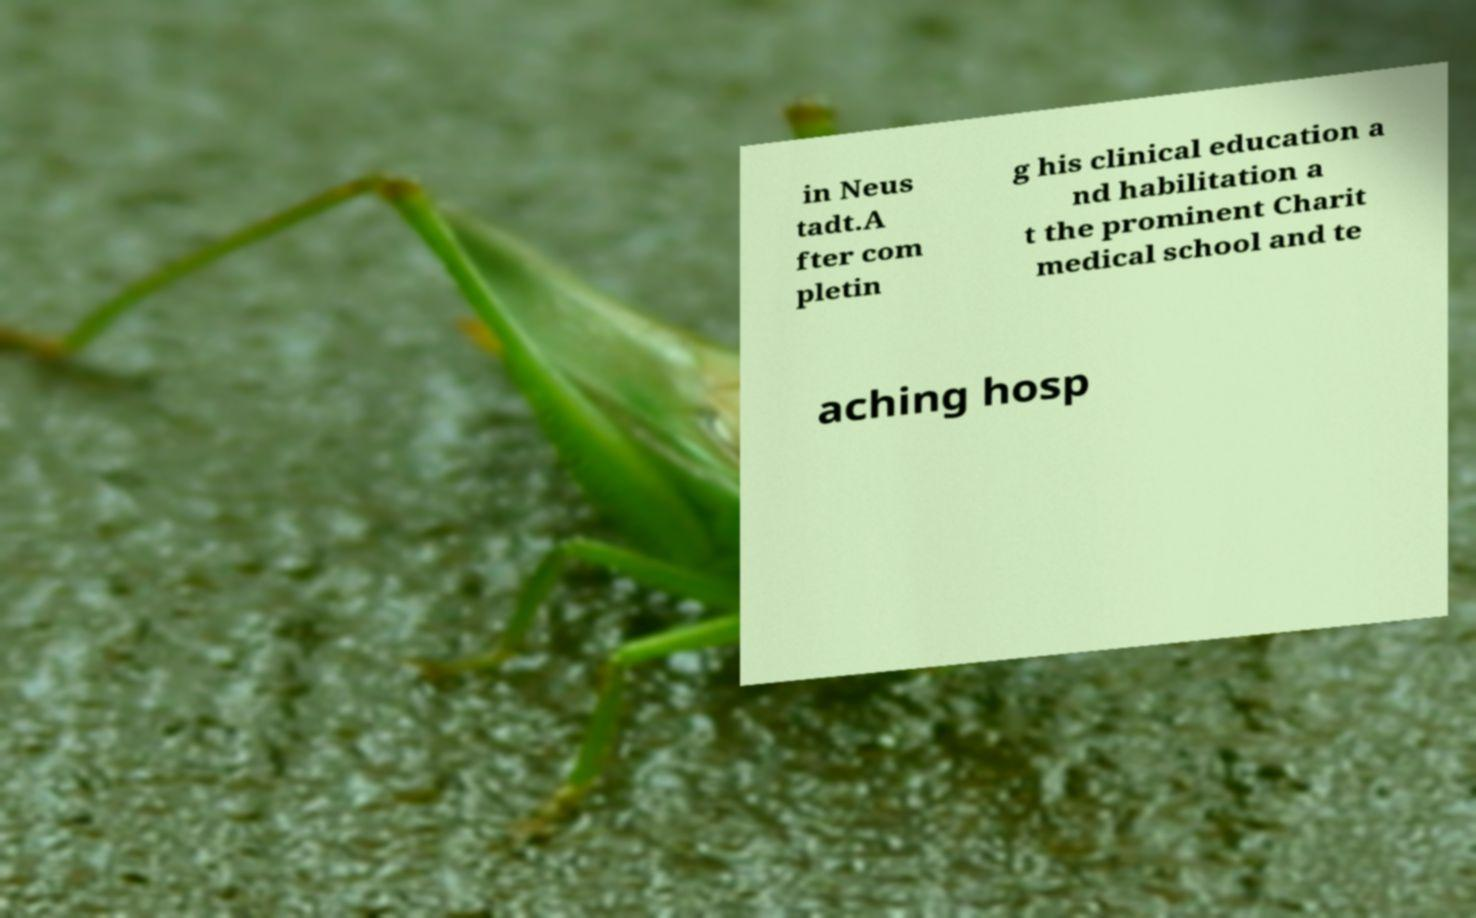Could you extract and type out the text from this image? in Neus tadt.A fter com pletin g his clinical education a nd habilitation a t the prominent Charit medical school and te aching hosp 